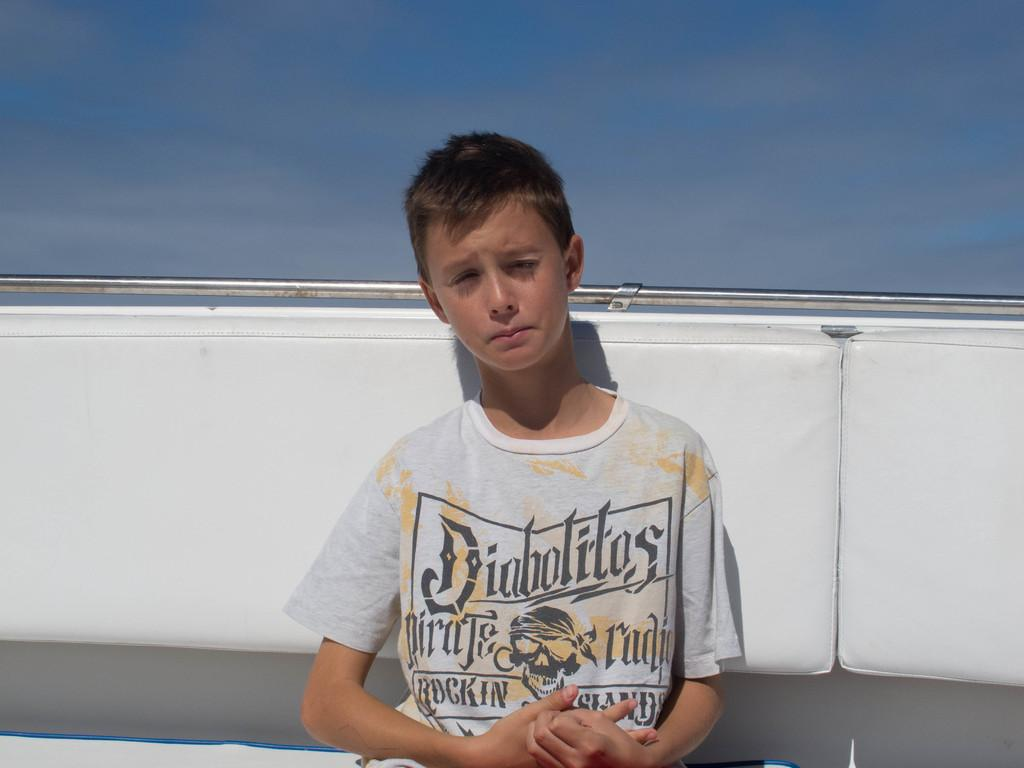Who is the main subject in the image? There is a boy in the image. What is the boy wearing? The boy is wearing a white t-shirt. Where is the boy sitting? The boy is sitting on a bench. What can be seen in the background of the image? The sky is visible in the image, and clouds are present in the sky. What type of food is the boy eating in the image? There is no food present in the image, so it cannot be determined what the boy might be eating. 